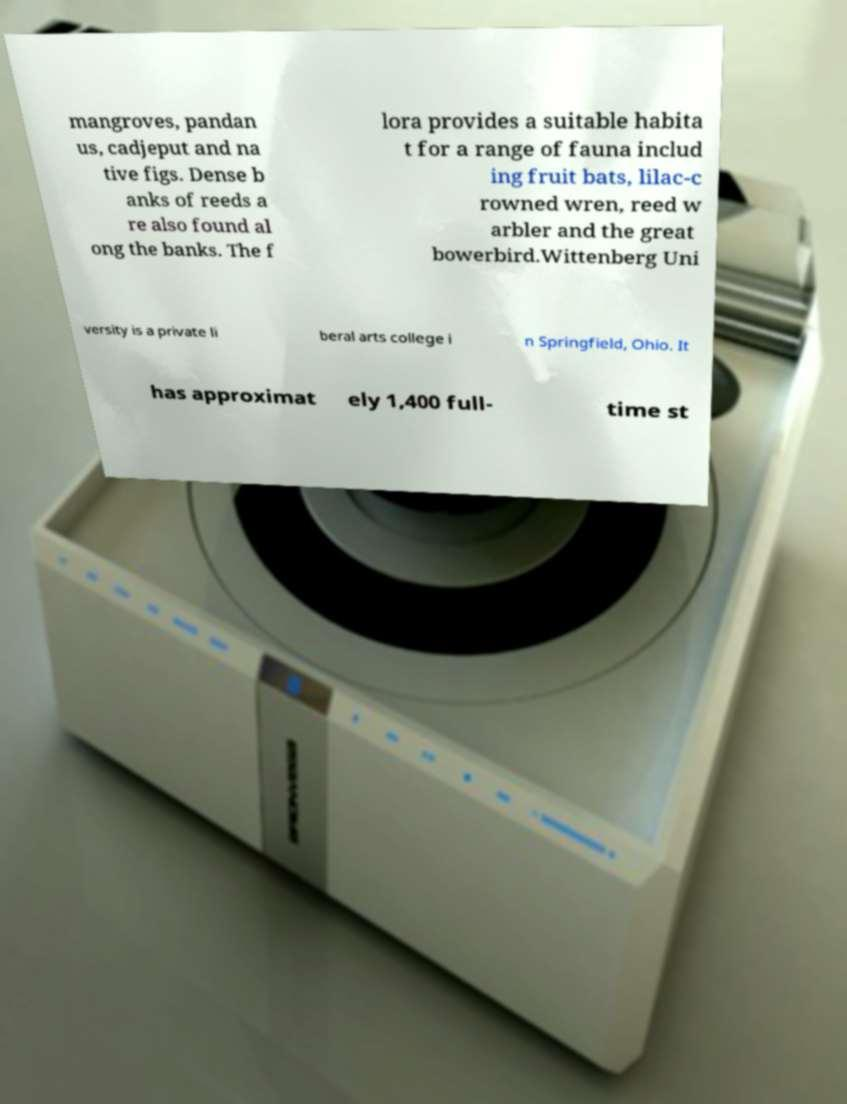Please read and relay the text visible in this image. What does it say? mangroves, pandan us, cadjeput and na tive figs. Dense b anks of reeds a re also found al ong the banks. The f lora provides a suitable habita t for a range of fauna includ ing fruit bats, lilac-c rowned wren, reed w arbler and the great bowerbird.Wittenberg Uni versity is a private li beral arts college i n Springfield, Ohio. It has approximat ely 1,400 full- time st 